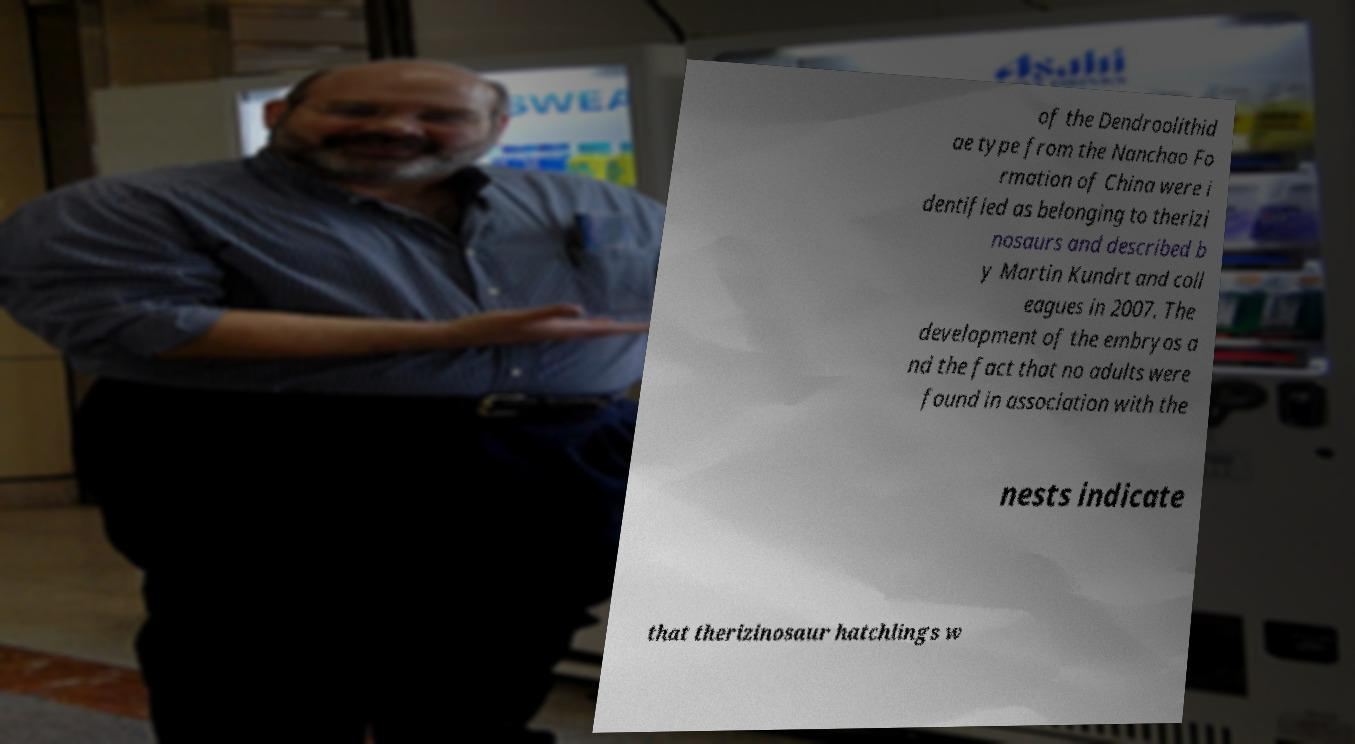Could you extract and type out the text from this image? of the Dendroolithid ae type from the Nanchao Fo rmation of China were i dentified as belonging to therizi nosaurs and described b y Martin Kundrt and coll eagues in 2007. The development of the embryos a nd the fact that no adults were found in association with the nests indicate that therizinosaur hatchlings w 